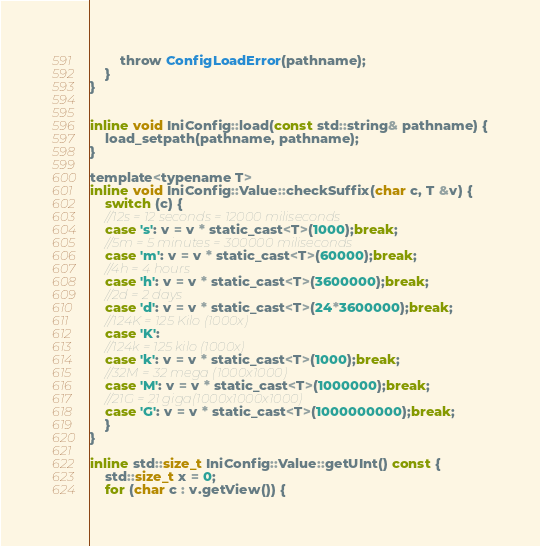Convert code to text. <code><loc_0><loc_0><loc_500><loc_500><_C_>		throw ConfigLoadError(pathname);
	}
}


inline void IniConfig::load(const std::string& pathname) {
	load_setpath(pathname, pathname);
}

template<typename T>
inline void IniConfig::Value::checkSuffix(char c, T &v) {
	switch (c) {
	//12s = 12 seconds = 12000 miliseconds
	case 's': v = v * static_cast<T>(1000);break;
	//5m = 5 minutes = 300000 miliseconds
	case 'm': v = v * static_cast<T>(60000);break;
	//4h = 4 hours
	case 'h': v = v * static_cast<T>(3600000);break;
	//2d = 2 days
	case 'd': v = v * static_cast<T>(24*3600000);break;
	//124K = 125 Kilo (1000x)
	case 'K':
	//124k = 125 kilo (1000x)
	case 'k': v = v * static_cast<T>(1000);break;
	//32M = 32 mega (1000x1000)
	case 'M': v = v * static_cast<T>(1000000);break;
	//21G = 21 giga(1000x1000x1000)
	case 'G': v = v * static_cast<T>(1000000000);break;
	}
}

inline std::size_t IniConfig::Value::getUInt() const {
	std::size_t x = 0;
	for (char c : v.getView()) {</code> 